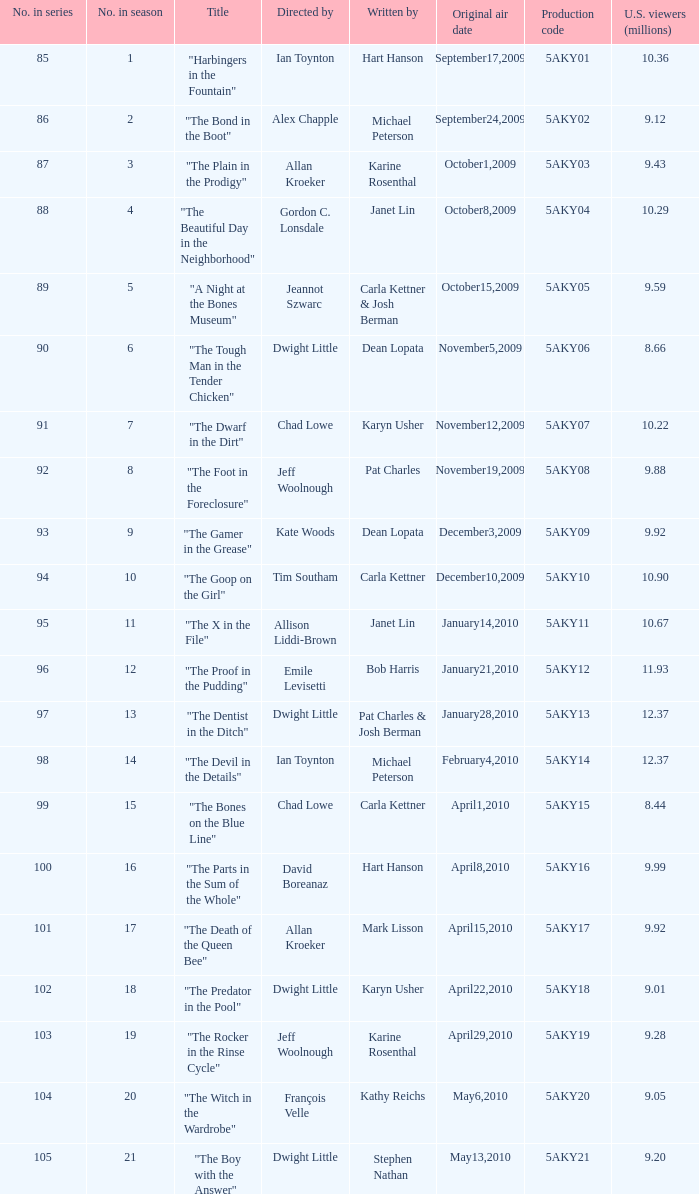Who was the writer of the episode with a production code of 5aky04? Janet Lin. 